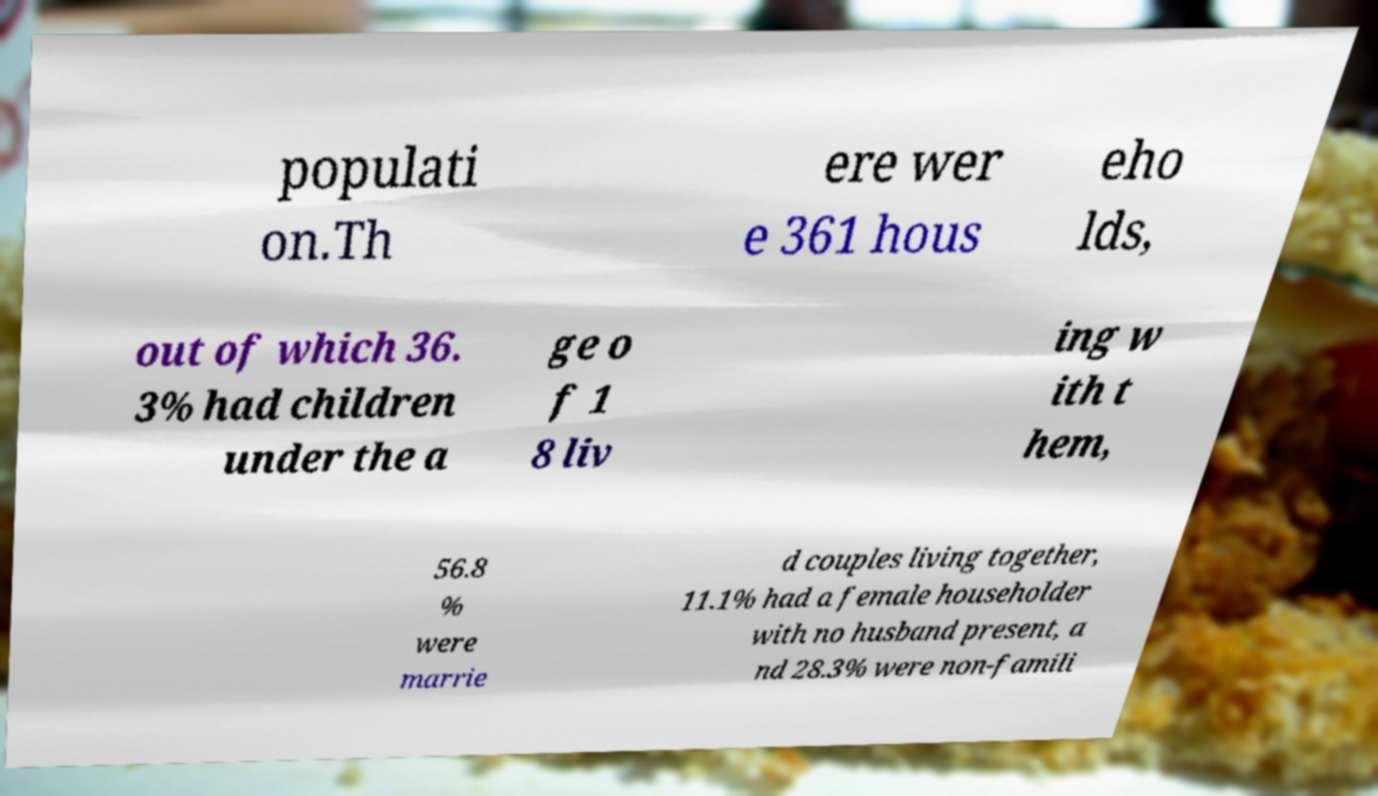Please identify and transcribe the text found in this image. populati on.Th ere wer e 361 hous eho lds, out of which 36. 3% had children under the a ge o f 1 8 liv ing w ith t hem, 56.8 % were marrie d couples living together, 11.1% had a female householder with no husband present, a nd 28.3% were non-famili 